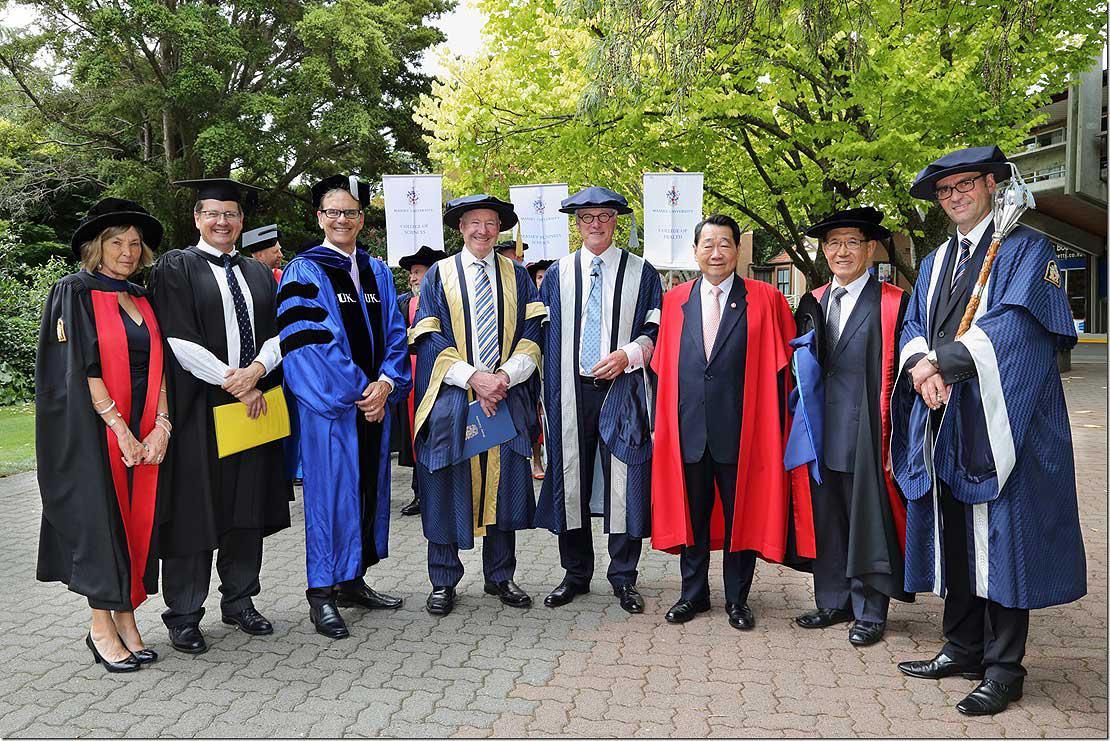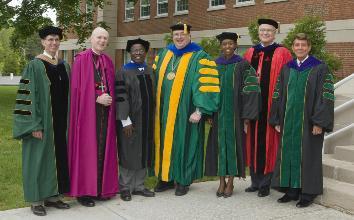The first image is the image on the left, the second image is the image on the right. Given the left and right images, does the statement "There are at least 14 graduates and/or professors, and some of them are not wearing caps on their heads." hold true? Answer yes or no. Yes. The first image is the image on the left, the second image is the image on the right. Examine the images to the left and right. Is the description "At least one person is holding a piece of paper." accurate? Answer yes or no. Yes. 